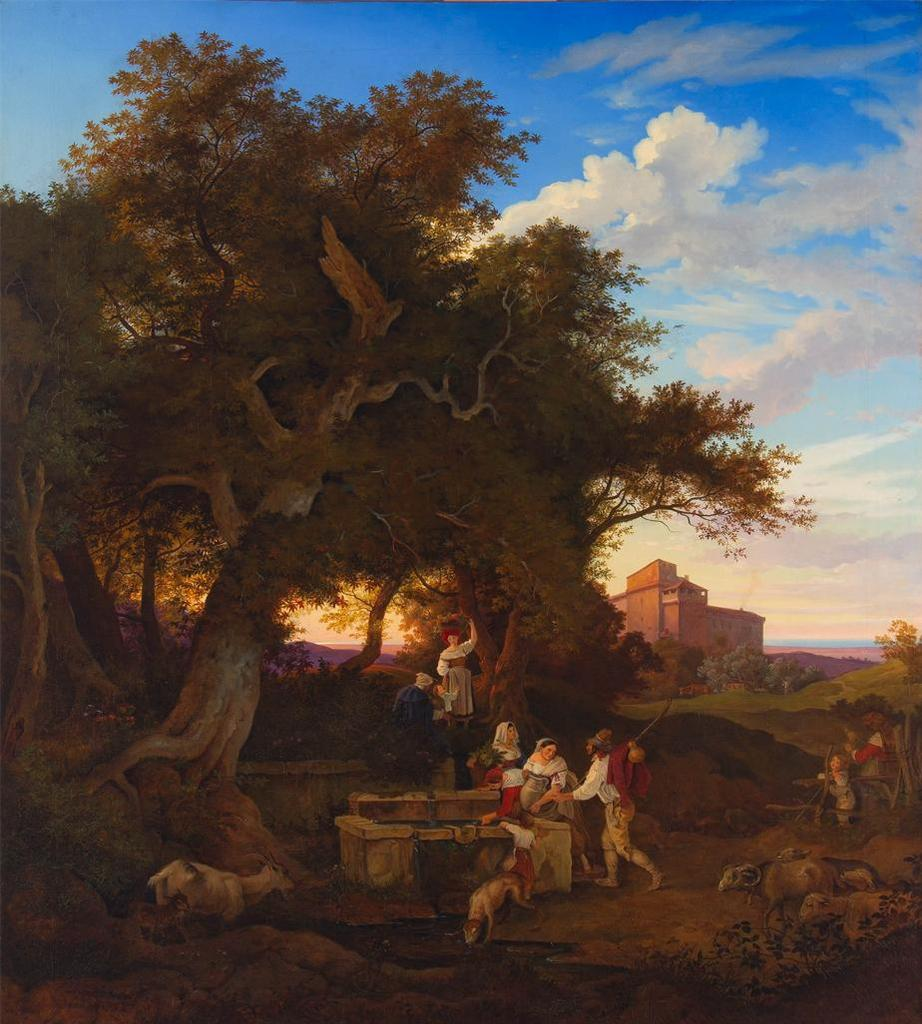What types of subjects can be seen in the painting? There are people and animals in the painting. Where are the people and animals located in the painting? They are under a tree in the painting. What can be seen in the background of the painting? There is a building in the background of the painting. What is the annual income of the queen in the painting? There is no queen present in the painting, and therefore no information about her income can be determined. 